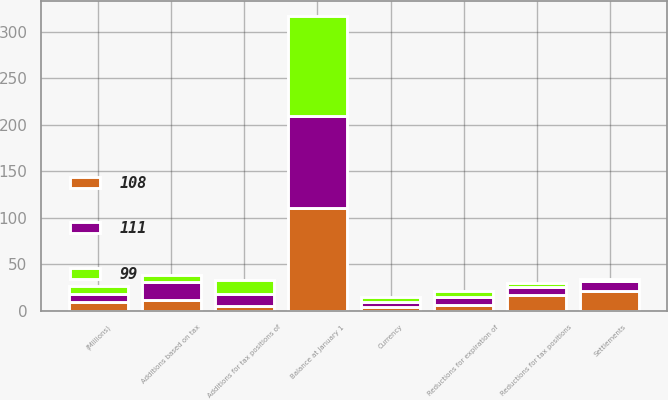Convert chart to OTSL. <chart><loc_0><loc_0><loc_500><loc_500><stacked_bar_chart><ecel><fcel>(Millions)<fcel>Balance at January 1<fcel>Additions based on tax<fcel>Additions for tax positions of<fcel>Reductions for tax positions<fcel>Reductions for expiration of<fcel>Settlements<fcel>Currency<nl><fcel>99<fcel>9<fcel>108<fcel>7<fcel>15<fcel>5<fcel>6<fcel>2<fcel>6<nl><fcel>111<fcel>9<fcel>99<fcel>19<fcel>13<fcel>8<fcel>9<fcel>11<fcel>5<nl><fcel>108<fcel>9<fcel>110<fcel>12<fcel>5<fcel>17<fcel>6<fcel>21<fcel>4<nl></chart> 